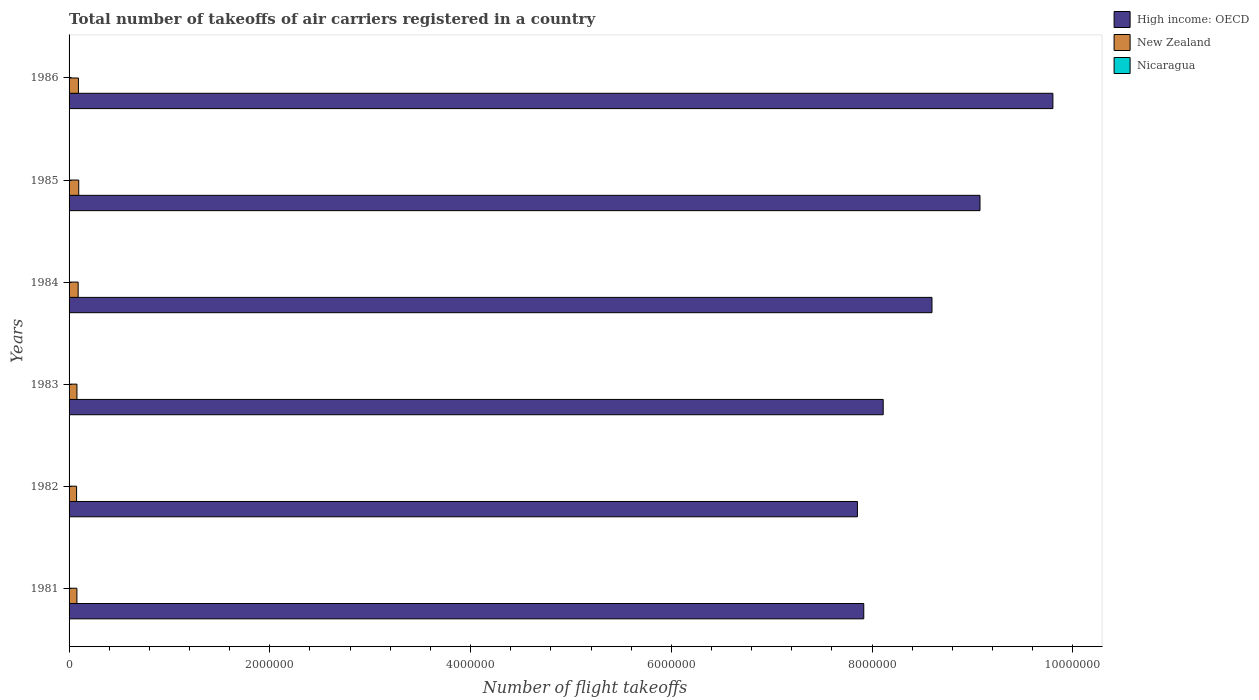How many different coloured bars are there?
Ensure brevity in your answer.  3. Are the number of bars per tick equal to the number of legend labels?
Provide a short and direct response. Yes. How many bars are there on the 1st tick from the top?
Make the answer very short. 3. In how many cases, is the number of bars for a given year not equal to the number of legend labels?
Provide a short and direct response. 0. What is the total number of flight takeoffs in New Zealand in 1984?
Offer a very short reply. 9.05e+04. Across all years, what is the maximum total number of flight takeoffs in New Zealand?
Your answer should be compact. 9.62e+04. Across all years, what is the minimum total number of flight takeoffs in New Zealand?
Your response must be concise. 7.50e+04. In which year was the total number of flight takeoffs in New Zealand minimum?
Your answer should be compact. 1982. What is the total total number of flight takeoffs in New Zealand in the graph?
Your response must be concise. 5.11e+05. What is the difference between the total number of flight takeoffs in Nicaragua in 1981 and that in 1985?
Provide a short and direct response. 1300. What is the difference between the total number of flight takeoffs in High income: OECD in 1985 and the total number of flight takeoffs in Nicaragua in 1982?
Your answer should be compact. 9.07e+06. What is the average total number of flight takeoffs in Nicaragua per year?
Your answer should be compact. 2300. In the year 1984, what is the difference between the total number of flight takeoffs in Nicaragua and total number of flight takeoffs in High income: OECD?
Provide a short and direct response. -8.59e+06. What is the ratio of the total number of flight takeoffs in High income: OECD in 1984 to that in 1985?
Give a very brief answer. 0.95. Is the total number of flight takeoffs in High income: OECD in 1982 less than that in 1983?
Keep it short and to the point. Yes. What is the difference between the highest and the second highest total number of flight takeoffs in High income: OECD?
Give a very brief answer. 7.26e+05. What is the difference between the highest and the lowest total number of flight takeoffs in High income: OECD?
Give a very brief answer. 1.95e+06. What does the 1st bar from the top in 1983 represents?
Offer a terse response. Nicaragua. What does the 3rd bar from the bottom in 1985 represents?
Provide a succinct answer. Nicaragua. Is it the case that in every year, the sum of the total number of flight takeoffs in Nicaragua and total number of flight takeoffs in High income: OECD is greater than the total number of flight takeoffs in New Zealand?
Your answer should be very brief. Yes. Are all the bars in the graph horizontal?
Make the answer very short. Yes. How many years are there in the graph?
Provide a succinct answer. 6. Are the values on the major ticks of X-axis written in scientific E-notation?
Your response must be concise. No. Does the graph contain grids?
Your response must be concise. No. How many legend labels are there?
Provide a succinct answer. 3. What is the title of the graph?
Keep it short and to the point. Total number of takeoffs of air carriers registered in a country. Does "World" appear as one of the legend labels in the graph?
Keep it short and to the point. No. What is the label or title of the X-axis?
Give a very brief answer. Number of flight takeoffs. What is the Number of flight takeoffs in High income: OECD in 1981?
Your answer should be compact. 7.92e+06. What is the Number of flight takeoffs in New Zealand in 1981?
Give a very brief answer. 7.80e+04. What is the Number of flight takeoffs in Nicaragua in 1981?
Provide a short and direct response. 3600. What is the Number of flight takeoffs of High income: OECD in 1982?
Offer a very short reply. 7.85e+06. What is the Number of flight takeoffs in New Zealand in 1982?
Keep it short and to the point. 7.50e+04. What is the Number of flight takeoffs in Nicaragua in 1982?
Provide a short and direct response. 1800. What is the Number of flight takeoffs of High income: OECD in 1983?
Keep it short and to the point. 8.11e+06. What is the Number of flight takeoffs in New Zealand in 1983?
Make the answer very short. 7.86e+04. What is the Number of flight takeoffs in Nicaragua in 1983?
Ensure brevity in your answer.  1900. What is the Number of flight takeoffs in High income: OECD in 1984?
Your answer should be compact. 8.60e+06. What is the Number of flight takeoffs in New Zealand in 1984?
Offer a very short reply. 9.05e+04. What is the Number of flight takeoffs in Nicaragua in 1984?
Offer a very short reply. 2200. What is the Number of flight takeoffs of High income: OECD in 1985?
Your answer should be compact. 9.08e+06. What is the Number of flight takeoffs in New Zealand in 1985?
Your answer should be compact. 9.62e+04. What is the Number of flight takeoffs of Nicaragua in 1985?
Your response must be concise. 2300. What is the Number of flight takeoffs in High income: OECD in 1986?
Your answer should be very brief. 9.80e+06. What is the Number of flight takeoffs in New Zealand in 1986?
Provide a short and direct response. 9.31e+04. What is the Number of flight takeoffs of Nicaragua in 1986?
Your answer should be compact. 2000. Across all years, what is the maximum Number of flight takeoffs in High income: OECD?
Offer a terse response. 9.80e+06. Across all years, what is the maximum Number of flight takeoffs in New Zealand?
Your response must be concise. 9.62e+04. Across all years, what is the maximum Number of flight takeoffs of Nicaragua?
Provide a succinct answer. 3600. Across all years, what is the minimum Number of flight takeoffs of High income: OECD?
Provide a succinct answer. 7.85e+06. Across all years, what is the minimum Number of flight takeoffs of New Zealand?
Ensure brevity in your answer.  7.50e+04. Across all years, what is the minimum Number of flight takeoffs in Nicaragua?
Keep it short and to the point. 1800. What is the total Number of flight takeoffs of High income: OECD in the graph?
Make the answer very short. 5.14e+07. What is the total Number of flight takeoffs of New Zealand in the graph?
Your answer should be very brief. 5.11e+05. What is the total Number of flight takeoffs of Nicaragua in the graph?
Your answer should be very brief. 1.38e+04. What is the difference between the Number of flight takeoffs of High income: OECD in 1981 and that in 1982?
Offer a terse response. 6.33e+04. What is the difference between the Number of flight takeoffs in New Zealand in 1981 and that in 1982?
Provide a succinct answer. 3000. What is the difference between the Number of flight takeoffs of Nicaragua in 1981 and that in 1982?
Your answer should be very brief. 1800. What is the difference between the Number of flight takeoffs in High income: OECD in 1981 and that in 1983?
Your answer should be very brief. -1.94e+05. What is the difference between the Number of flight takeoffs of New Zealand in 1981 and that in 1983?
Offer a terse response. -600. What is the difference between the Number of flight takeoffs in Nicaragua in 1981 and that in 1983?
Keep it short and to the point. 1700. What is the difference between the Number of flight takeoffs in High income: OECD in 1981 and that in 1984?
Your response must be concise. -6.80e+05. What is the difference between the Number of flight takeoffs in New Zealand in 1981 and that in 1984?
Make the answer very short. -1.25e+04. What is the difference between the Number of flight takeoffs of Nicaragua in 1981 and that in 1984?
Your response must be concise. 1400. What is the difference between the Number of flight takeoffs in High income: OECD in 1981 and that in 1985?
Your answer should be compact. -1.16e+06. What is the difference between the Number of flight takeoffs of New Zealand in 1981 and that in 1985?
Your response must be concise. -1.82e+04. What is the difference between the Number of flight takeoffs in Nicaragua in 1981 and that in 1985?
Give a very brief answer. 1300. What is the difference between the Number of flight takeoffs of High income: OECD in 1981 and that in 1986?
Provide a short and direct response. -1.88e+06. What is the difference between the Number of flight takeoffs in New Zealand in 1981 and that in 1986?
Your answer should be very brief. -1.51e+04. What is the difference between the Number of flight takeoffs in Nicaragua in 1981 and that in 1986?
Your answer should be compact. 1600. What is the difference between the Number of flight takeoffs in High income: OECD in 1982 and that in 1983?
Offer a very short reply. -2.57e+05. What is the difference between the Number of flight takeoffs in New Zealand in 1982 and that in 1983?
Provide a short and direct response. -3600. What is the difference between the Number of flight takeoffs in Nicaragua in 1982 and that in 1983?
Offer a terse response. -100. What is the difference between the Number of flight takeoffs of High income: OECD in 1982 and that in 1984?
Your answer should be compact. -7.43e+05. What is the difference between the Number of flight takeoffs in New Zealand in 1982 and that in 1984?
Your answer should be compact. -1.55e+04. What is the difference between the Number of flight takeoffs of Nicaragua in 1982 and that in 1984?
Your response must be concise. -400. What is the difference between the Number of flight takeoffs in High income: OECD in 1982 and that in 1985?
Your response must be concise. -1.22e+06. What is the difference between the Number of flight takeoffs in New Zealand in 1982 and that in 1985?
Provide a succinct answer. -2.12e+04. What is the difference between the Number of flight takeoffs in Nicaragua in 1982 and that in 1985?
Give a very brief answer. -500. What is the difference between the Number of flight takeoffs of High income: OECD in 1982 and that in 1986?
Provide a succinct answer. -1.95e+06. What is the difference between the Number of flight takeoffs of New Zealand in 1982 and that in 1986?
Ensure brevity in your answer.  -1.81e+04. What is the difference between the Number of flight takeoffs of Nicaragua in 1982 and that in 1986?
Make the answer very short. -200. What is the difference between the Number of flight takeoffs of High income: OECD in 1983 and that in 1984?
Make the answer very short. -4.86e+05. What is the difference between the Number of flight takeoffs of New Zealand in 1983 and that in 1984?
Keep it short and to the point. -1.19e+04. What is the difference between the Number of flight takeoffs of Nicaragua in 1983 and that in 1984?
Provide a short and direct response. -300. What is the difference between the Number of flight takeoffs of High income: OECD in 1983 and that in 1985?
Provide a succinct answer. -9.64e+05. What is the difference between the Number of flight takeoffs in New Zealand in 1983 and that in 1985?
Provide a succinct answer. -1.76e+04. What is the difference between the Number of flight takeoffs of Nicaragua in 1983 and that in 1985?
Give a very brief answer. -400. What is the difference between the Number of flight takeoffs of High income: OECD in 1983 and that in 1986?
Provide a short and direct response. -1.69e+06. What is the difference between the Number of flight takeoffs of New Zealand in 1983 and that in 1986?
Make the answer very short. -1.45e+04. What is the difference between the Number of flight takeoffs of Nicaragua in 1983 and that in 1986?
Your answer should be compact. -100. What is the difference between the Number of flight takeoffs in High income: OECD in 1984 and that in 1985?
Make the answer very short. -4.78e+05. What is the difference between the Number of flight takeoffs of New Zealand in 1984 and that in 1985?
Your response must be concise. -5700. What is the difference between the Number of flight takeoffs of Nicaragua in 1984 and that in 1985?
Ensure brevity in your answer.  -100. What is the difference between the Number of flight takeoffs of High income: OECD in 1984 and that in 1986?
Ensure brevity in your answer.  -1.20e+06. What is the difference between the Number of flight takeoffs of New Zealand in 1984 and that in 1986?
Make the answer very short. -2600. What is the difference between the Number of flight takeoffs in Nicaragua in 1984 and that in 1986?
Offer a terse response. 200. What is the difference between the Number of flight takeoffs in High income: OECD in 1985 and that in 1986?
Offer a very short reply. -7.26e+05. What is the difference between the Number of flight takeoffs of New Zealand in 1985 and that in 1986?
Give a very brief answer. 3100. What is the difference between the Number of flight takeoffs of Nicaragua in 1985 and that in 1986?
Your answer should be very brief. 300. What is the difference between the Number of flight takeoffs in High income: OECD in 1981 and the Number of flight takeoffs in New Zealand in 1982?
Offer a very short reply. 7.84e+06. What is the difference between the Number of flight takeoffs in High income: OECD in 1981 and the Number of flight takeoffs in Nicaragua in 1982?
Keep it short and to the point. 7.92e+06. What is the difference between the Number of flight takeoffs of New Zealand in 1981 and the Number of flight takeoffs of Nicaragua in 1982?
Keep it short and to the point. 7.62e+04. What is the difference between the Number of flight takeoffs of High income: OECD in 1981 and the Number of flight takeoffs of New Zealand in 1983?
Your answer should be compact. 7.84e+06. What is the difference between the Number of flight takeoffs in High income: OECD in 1981 and the Number of flight takeoffs in Nicaragua in 1983?
Your answer should be compact. 7.92e+06. What is the difference between the Number of flight takeoffs of New Zealand in 1981 and the Number of flight takeoffs of Nicaragua in 1983?
Make the answer very short. 7.61e+04. What is the difference between the Number of flight takeoffs in High income: OECD in 1981 and the Number of flight takeoffs in New Zealand in 1984?
Your answer should be compact. 7.83e+06. What is the difference between the Number of flight takeoffs of High income: OECD in 1981 and the Number of flight takeoffs of Nicaragua in 1984?
Make the answer very short. 7.91e+06. What is the difference between the Number of flight takeoffs of New Zealand in 1981 and the Number of flight takeoffs of Nicaragua in 1984?
Keep it short and to the point. 7.58e+04. What is the difference between the Number of flight takeoffs of High income: OECD in 1981 and the Number of flight takeoffs of New Zealand in 1985?
Your answer should be very brief. 7.82e+06. What is the difference between the Number of flight takeoffs in High income: OECD in 1981 and the Number of flight takeoffs in Nicaragua in 1985?
Your answer should be very brief. 7.91e+06. What is the difference between the Number of flight takeoffs of New Zealand in 1981 and the Number of flight takeoffs of Nicaragua in 1985?
Offer a very short reply. 7.57e+04. What is the difference between the Number of flight takeoffs in High income: OECD in 1981 and the Number of flight takeoffs in New Zealand in 1986?
Provide a succinct answer. 7.82e+06. What is the difference between the Number of flight takeoffs in High income: OECD in 1981 and the Number of flight takeoffs in Nicaragua in 1986?
Your answer should be very brief. 7.92e+06. What is the difference between the Number of flight takeoffs in New Zealand in 1981 and the Number of flight takeoffs in Nicaragua in 1986?
Make the answer very short. 7.60e+04. What is the difference between the Number of flight takeoffs of High income: OECD in 1982 and the Number of flight takeoffs of New Zealand in 1983?
Provide a succinct answer. 7.78e+06. What is the difference between the Number of flight takeoffs in High income: OECD in 1982 and the Number of flight takeoffs in Nicaragua in 1983?
Keep it short and to the point. 7.85e+06. What is the difference between the Number of flight takeoffs of New Zealand in 1982 and the Number of flight takeoffs of Nicaragua in 1983?
Provide a succinct answer. 7.31e+04. What is the difference between the Number of flight takeoffs in High income: OECD in 1982 and the Number of flight takeoffs in New Zealand in 1984?
Ensure brevity in your answer.  7.76e+06. What is the difference between the Number of flight takeoffs of High income: OECD in 1982 and the Number of flight takeoffs of Nicaragua in 1984?
Your response must be concise. 7.85e+06. What is the difference between the Number of flight takeoffs in New Zealand in 1982 and the Number of flight takeoffs in Nicaragua in 1984?
Offer a terse response. 7.28e+04. What is the difference between the Number of flight takeoffs of High income: OECD in 1982 and the Number of flight takeoffs of New Zealand in 1985?
Keep it short and to the point. 7.76e+06. What is the difference between the Number of flight takeoffs in High income: OECD in 1982 and the Number of flight takeoffs in Nicaragua in 1985?
Ensure brevity in your answer.  7.85e+06. What is the difference between the Number of flight takeoffs of New Zealand in 1982 and the Number of flight takeoffs of Nicaragua in 1985?
Your answer should be very brief. 7.27e+04. What is the difference between the Number of flight takeoffs in High income: OECD in 1982 and the Number of flight takeoffs in New Zealand in 1986?
Ensure brevity in your answer.  7.76e+06. What is the difference between the Number of flight takeoffs in High income: OECD in 1982 and the Number of flight takeoffs in Nicaragua in 1986?
Offer a very short reply. 7.85e+06. What is the difference between the Number of flight takeoffs of New Zealand in 1982 and the Number of flight takeoffs of Nicaragua in 1986?
Provide a succinct answer. 7.30e+04. What is the difference between the Number of flight takeoffs of High income: OECD in 1983 and the Number of flight takeoffs of New Zealand in 1984?
Offer a very short reply. 8.02e+06. What is the difference between the Number of flight takeoffs of High income: OECD in 1983 and the Number of flight takeoffs of Nicaragua in 1984?
Offer a very short reply. 8.11e+06. What is the difference between the Number of flight takeoffs in New Zealand in 1983 and the Number of flight takeoffs in Nicaragua in 1984?
Your response must be concise. 7.64e+04. What is the difference between the Number of flight takeoffs of High income: OECD in 1983 and the Number of flight takeoffs of New Zealand in 1985?
Provide a succinct answer. 8.01e+06. What is the difference between the Number of flight takeoffs in High income: OECD in 1983 and the Number of flight takeoffs in Nicaragua in 1985?
Ensure brevity in your answer.  8.11e+06. What is the difference between the Number of flight takeoffs of New Zealand in 1983 and the Number of flight takeoffs of Nicaragua in 1985?
Make the answer very short. 7.63e+04. What is the difference between the Number of flight takeoffs of High income: OECD in 1983 and the Number of flight takeoffs of New Zealand in 1986?
Keep it short and to the point. 8.02e+06. What is the difference between the Number of flight takeoffs of High income: OECD in 1983 and the Number of flight takeoffs of Nicaragua in 1986?
Give a very brief answer. 8.11e+06. What is the difference between the Number of flight takeoffs in New Zealand in 1983 and the Number of flight takeoffs in Nicaragua in 1986?
Your response must be concise. 7.66e+04. What is the difference between the Number of flight takeoffs of High income: OECD in 1984 and the Number of flight takeoffs of New Zealand in 1985?
Make the answer very short. 8.50e+06. What is the difference between the Number of flight takeoffs of High income: OECD in 1984 and the Number of flight takeoffs of Nicaragua in 1985?
Provide a succinct answer. 8.59e+06. What is the difference between the Number of flight takeoffs of New Zealand in 1984 and the Number of flight takeoffs of Nicaragua in 1985?
Offer a very short reply. 8.82e+04. What is the difference between the Number of flight takeoffs of High income: OECD in 1984 and the Number of flight takeoffs of New Zealand in 1986?
Your response must be concise. 8.50e+06. What is the difference between the Number of flight takeoffs in High income: OECD in 1984 and the Number of flight takeoffs in Nicaragua in 1986?
Provide a short and direct response. 8.59e+06. What is the difference between the Number of flight takeoffs in New Zealand in 1984 and the Number of flight takeoffs in Nicaragua in 1986?
Your answer should be compact. 8.85e+04. What is the difference between the Number of flight takeoffs in High income: OECD in 1985 and the Number of flight takeoffs in New Zealand in 1986?
Ensure brevity in your answer.  8.98e+06. What is the difference between the Number of flight takeoffs of High income: OECD in 1985 and the Number of flight takeoffs of Nicaragua in 1986?
Your response must be concise. 9.07e+06. What is the difference between the Number of flight takeoffs of New Zealand in 1985 and the Number of flight takeoffs of Nicaragua in 1986?
Make the answer very short. 9.42e+04. What is the average Number of flight takeoffs of High income: OECD per year?
Ensure brevity in your answer.  8.56e+06. What is the average Number of flight takeoffs in New Zealand per year?
Ensure brevity in your answer.  8.52e+04. What is the average Number of flight takeoffs of Nicaragua per year?
Make the answer very short. 2300. In the year 1981, what is the difference between the Number of flight takeoffs of High income: OECD and Number of flight takeoffs of New Zealand?
Your response must be concise. 7.84e+06. In the year 1981, what is the difference between the Number of flight takeoffs of High income: OECD and Number of flight takeoffs of Nicaragua?
Give a very brief answer. 7.91e+06. In the year 1981, what is the difference between the Number of flight takeoffs in New Zealand and Number of flight takeoffs in Nicaragua?
Offer a very short reply. 7.44e+04. In the year 1982, what is the difference between the Number of flight takeoffs in High income: OECD and Number of flight takeoffs in New Zealand?
Make the answer very short. 7.78e+06. In the year 1982, what is the difference between the Number of flight takeoffs of High income: OECD and Number of flight takeoffs of Nicaragua?
Offer a very short reply. 7.85e+06. In the year 1982, what is the difference between the Number of flight takeoffs of New Zealand and Number of flight takeoffs of Nicaragua?
Offer a very short reply. 7.32e+04. In the year 1983, what is the difference between the Number of flight takeoffs in High income: OECD and Number of flight takeoffs in New Zealand?
Provide a succinct answer. 8.03e+06. In the year 1983, what is the difference between the Number of flight takeoffs of High income: OECD and Number of flight takeoffs of Nicaragua?
Your answer should be very brief. 8.11e+06. In the year 1983, what is the difference between the Number of flight takeoffs in New Zealand and Number of flight takeoffs in Nicaragua?
Ensure brevity in your answer.  7.67e+04. In the year 1984, what is the difference between the Number of flight takeoffs of High income: OECD and Number of flight takeoffs of New Zealand?
Your answer should be very brief. 8.51e+06. In the year 1984, what is the difference between the Number of flight takeoffs of High income: OECD and Number of flight takeoffs of Nicaragua?
Keep it short and to the point. 8.59e+06. In the year 1984, what is the difference between the Number of flight takeoffs in New Zealand and Number of flight takeoffs in Nicaragua?
Make the answer very short. 8.83e+04. In the year 1985, what is the difference between the Number of flight takeoffs in High income: OECD and Number of flight takeoffs in New Zealand?
Your response must be concise. 8.98e+06. In the year 1985, what is the difference between the Number of flight takeoffs in High income: OECD and Number of flight takeoffs in Nicaragua?
Provide a short and direct response. 9.07e+06. In the year 1985, what is the difference between the Number of flight takeoffs in New Zealand and Number of flight takeoffs in Nicaragua?
Provide a succinct answer. 9.39e+04. In the year 1986, what is the difference between the Number of flight takeoffs of High income: OECD and Number of flight takeoffs of New Zealand?
Offer a very short reply. 9.71e+06. In the year 1986, what is the difference between the Number of flight takeoffs in High income: OECD and Number of flight takeoffs in Nicaragua?
Give a very brief answer. 9.80e+06. In the year 1986, what is the difference between the Number of flight takeoffs in New Zealand and Number of flight takeoffs in Nicaragua?
Offer a terse response. 9.11e+04. What is the ratio of the Number of flight takeoffs in New Zealand in 1981 to that in 1982?
Ensure brevity in your answer.  1.04. What is the ratio of the Number of flight takeoffs of High income: OECD in 1981 to that in 1983?
Keep it short and to the point. 0.98. What is the ratio of the Number of flight takeoffs in New Zealand in 1981 to that in 1983?
Make the answer very short. 0.99. What is the ratio of the Number of flight takeoffs in Nicaragua in 1981 to that in 1983?
Your answer should be very brief. 1.89. What is the ratio of the Number of flight takeoffs in High income: OECD in 1981 to that in 1984?
Give a very brief answer. 0.92. What is the ratio of the Number of flight takeoffs in New Zealand in 1981 to that in 1984?
Make the answer very short. 0.86. What is the ratio of the Number of flight takeoffs of Nicaragua in 1981 to that in 1984?
Give a very brief answer. 1.64. What is the ratio of the Number of flight takeoffs of High income: OECD in 1981 to that in 1985?
Offer a very short reply. 0.87. What is the ratio of the Number of flight takeoffs of New Zealand in 1981 to that in 1985?
Keep it short and to the point. 0.81. What is the ratio of the Number of flight takeoffs in Nicaragua in 1981 to that in 1985?
Provide a succinct answer. 1.57. What is the ratio of the Number of flight takeoffs of High income: OECD in 1981 to that in 1986?
Offer a very short reply. 0.81. What is the ratio of the Number of flight takeoffs of New Zealand in 1981 to that in 1986?
Your answer should be very brief. 0.84. What is the ratio of the Number of flight takeoffs of Nicaragua in 1981 to that in 1986?
Keep it short and to the point. 1.8. What is the ratio of the Number of flight takeoffs in High income: OECD in 1982 to that in 1983?
Provide a short and direct response. 0.97. What is the ratio of the Number of flight takeoffs in New Zealand in 1982 to that in 1983?
Ensure brevity in your answer.  0.95. What is the ratio of the Number of flight takeoffs of High income: OECD in 1982 to that in 1984?
Offer a terse response. 0.91. What is the ratio of the Number of flight takeoffs in New Zealand in 1982 to that in 1984?
Keep it short and to the point. 0.83. What is the ratio of the Number of flight takeoffs in Nicaragua in 1982 to that in 1984?
Ensure brevity in your answer.  0.82. What is the ratio of the Number of flight takeoffs in High income: OECD in 1982 to that in 1985?
Your answer should be very brief. 0.87. What is the ratio of the Number of flight takeoffs in New Zealand in 1982 to that in 1985?
Offer a terse response. 0.78. What is the ratio of the Number of flight takeoffs of Nicaragua in 1982 to that in 1985?
Your answer should be compact. 0.78. What is the ratio of the Number of flight takeoffs of High income: OECD in 1982 to that in 1986?
Provide a short and direct response. 0.8. What is the ratio of the Number of flight takeoffs of New Zealand in 1982 to that in 1986?
Your response must be concise. 0.81. What is the ratio of the Number of flight takeoffs of Nicaragua in 1982 to that in 1986?
Keep it short and to the point. 0.9. What is the ratio of the Number of flight takeoffs of High income: OECD in 1983 to that in 1984?
Your answer should be very brief. 0.94. What is the ratio of the Number of flight takeoffs of New Zealand in 1983 to that in 1984?
Make the answer very short. 0.87. What is the ratio of the Number of flight takeoffs in Nicaragua in 1983 to that in 1984?
Provide a succinct answer. 0.86. What is the ratio of the Number of flight takeoffs in High income: OECD in 1983 to that in 1985?
Your answer should be very brief. 0.89. What is the ratio of the Number of flight takeoffs in New Zealand in 1983 to that in 1985?
Make the answer very short. 0.82. What is the ratio of the Number of flight takeoffs of Nicaragua in 1983 to that in 1985?
Provide a short and direct response. 0.83. What is the ratio of the Number of flight takeoffs of High income: OECD in 1983 to that in 1986?
Offer a very short reply. 0.83. What is the ratio of the Number of flight takeoffs in New Zealand in 1983 to that in 1986?
Provide a succinct answer. 0.84. What is the ratio of the Number of flight takeoffs in High income: OECD in 1984 to that in 1985?
Give a very brief answer. 0.95. What is the ratio of the Number of flight takeoffs in New Zealand in 1984 to that in 1985?
Provide a short and direct response. 0.94. What is the ratio of the Number of flight takeoffs in Nicaragua in 1984 to that in 1985?
Your response must be concise. 0.96. What is the ratio of the Number of flight takeoffs in High income: OECD in 1984 to that in 1986?
Your answer should be compact. 0.88. What is the ratio of the Number of flight takeoffs of New Zealand in 1984 to that in 1986?
Your answer should be very brief. 0.97. What is the ratio of the Number of flight takeoffs of Nicaragua in 1984 to that in 1986?
Offer a very short reply. 1.1. What is the ratio of the Number of flight takeoffs in High income: OECD in 1985 to that in 1986?
Your answer should be compact. 0.93. What is the ratio of the Number of flight takeoffs in Nicaragua in 1985 to that in 1986?
Ensure brevity in your answer.  1.15. What is the difference between the highest and the second highest Number of flight takeoffs of High income: OECD?
Your response must be concise. 7.26e+05. What is the difference between the highest and the second highest Number of flight takeoffs of New Zealand?
Your answer should be compact. 3100. What is the difference between the highest and the second highest Number of flight takeoffs of Nicaragua?
Offer a terse response. 1300. What is the difference between the highest and the lowest Number of flight takeoffs in High income: OECD?
Make the answer very short. 1.95e+06. What is the difference between the highest and the lowest Number of flight takeoffs of New Zealand?
Your answer should be very brief. 2.12e+04. What is the difference between the highest and the lowest Number of flight takeoffs of Nicaragua?
Your answer should be very brief. 1800. 